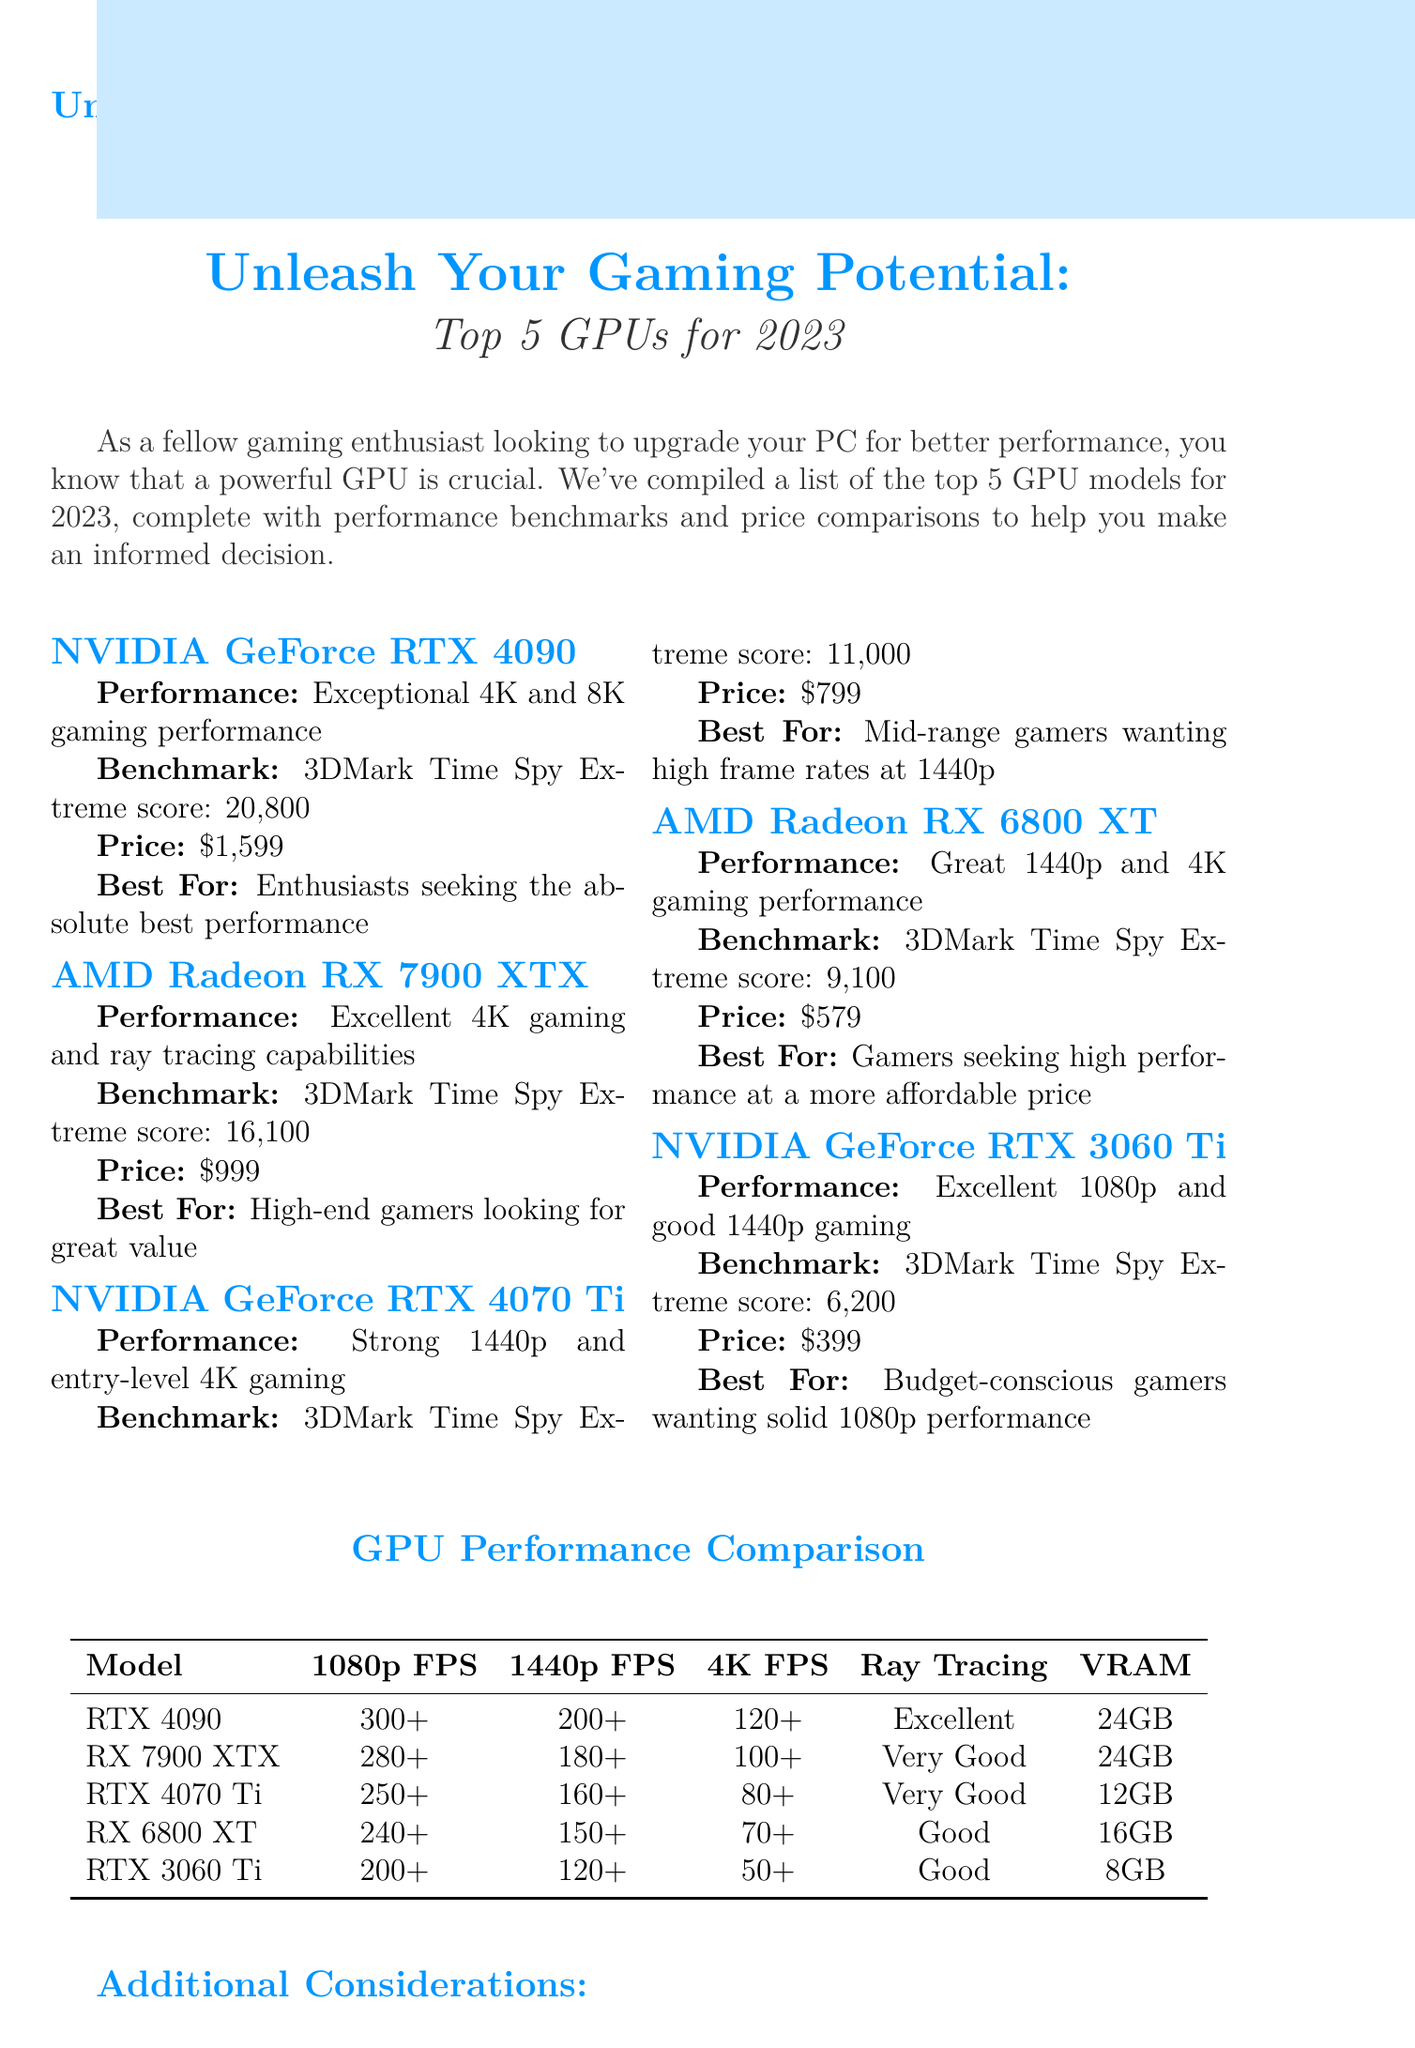What is the price of the NVIDIA GeForce RTX 4090? The price of the NVIDIA GeForce RTX 4090 is listed in the document as $1,599.
Answer: $1,599 What is the 3DMark Time Spy Extreme score for the AMD Radeon RX 6800 XT? The document provides the benchmark score for the AMD Radeon RX 6800 XT as 9,100 in the performance section.
Answer: 9,100 Which GPU is recommended for budget-conscious gamers? The document states that the NVIDIA GeForce RTX 3060 Ti is best for budget-conscious gamers wanting solid 1080p performance.
Answer: NVIDIA GeForce RTX 3060 Ti What is the maximum FPS for 1440p with the RX 7900 XTX? The maximum FPS for 1440p with the RX 7900 XTX is listed as 180+ in the comparison table.
Answer: 180+ How many GPUs have 24GB of VRAM? The document mentions that both the NVIDIA GeForce RTX 4090 and the AMD Radeon RX 7900 XTX have 24GB of VRAM.
Answer: 2 What additional consideration relates to future game optimization? The document lists "Future game optimization" as an additional consideration that gamers should take into account when choosing a GPU.
Answer: Future game optimization What is the recommended GPU for enthusiasts seeking the absolute best performance? The NVIDIA GeForce RTX 4090 is highlighted as the recommended GPU for enthusiasts seeking the absolute best performance.
Answer: NVIDIA GeForce RTX 4090 What is the main focus of the newsletter? The newsletter's main focus is to help gaming enthusiasts upgrade their PCs with the best GPUs for 2023, complete with benchmarks and price comparisons.
Answer: Upgrading PCs with the best GPUs for 2023 